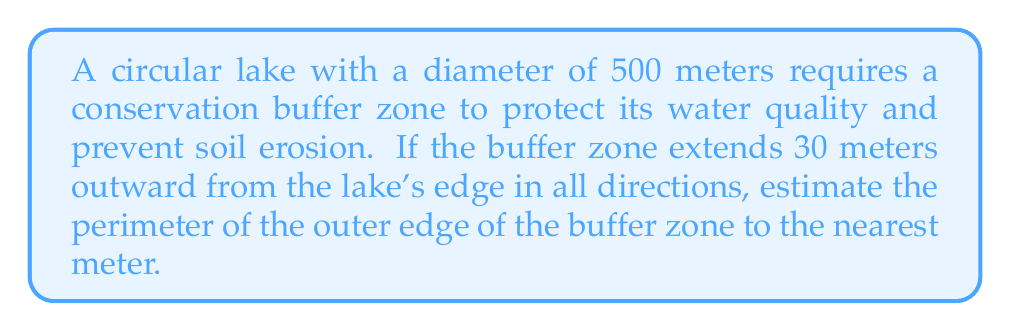Show me your answer to this math problem. Let's approach this step-by-step:

1) First, we need to find the radius of the lake:
   Diameter = 500 m, so radius = 500 ÷ 2 = 250 m

2) The buffer zone extends 30 m outward, so the radius of the entire area (lake + buffer) is:
   $r = 250 + 30 = 280$ m

3) To find the perimeter, we use the formula for the circumference of a circle:
   $C = 2\pi r$

4) Substituting our value for r:
   $C = 2\pi(280)$

5) Calculate:
   $C = 560\pi \approx 1758.4$ m

6) Rounding to the nearest meter:
   Perimeter ≈ 1758 m

[asy]
unitsize(0.4mm);
fill(circle((0,0),250), rgb(0.7,0.9,1));
draw(circle((0,0),250));
draw(circle((0,0),280), rgb(0,0.7,0));
label("Lake", (0,0));
label("Buffer zone", (265,0), E);
draw((250,0)--(280,0), Arrow);
label("30m", (265,10), N);
[/asy]
Answer: 1758 m 